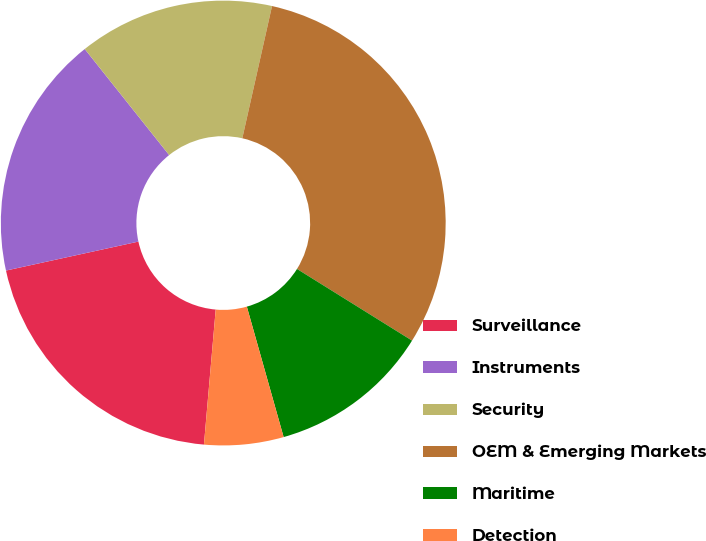Convert chart to OTSL. <chart><loc_0><loc_0><loc_500><loc_500><pie_chart><fcel>Surveillance<fcel>Instruments<fcel>Security<fcel>OEM & Emerging Markets<fcel>Maritime<fcel>Detection<nl><fcel>20.19%<fcel>17.73%<fcel>14.22%<fcel>30.35%<fcel>11.76%<fcel>5.76%<nl></chart> 